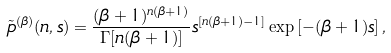Convert formula to latex. <formula><loc_0><loc_0><loc_500><loc_500>\tilde { p } ^ { ( \beta ) } ( n , s ) = \frac { ( \beta + 1 ) ^ { n ( \beta + 1 ) } } { \Gamma [ n ( \beta + 1 ) ] } s ^ { [ n ( \beta + 1 ) - 1 ] } \exp { \left [ - ( \beta + 1 ) s \right ] } \, ,</formula> 